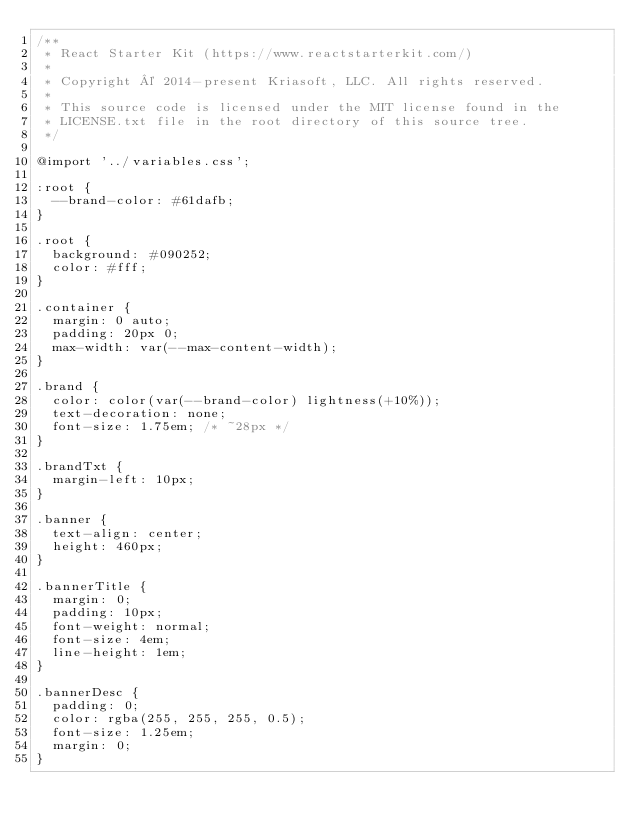<code> <loc_0><loc_0><loc_500><loc_500><_CSS_>/**
 * React Starter Kit (https://www.reactstarterkit.com/)
 *
 * Copyright © 2014-present Kriasoft, LLC. All rights reserved.
 *
 * This source code is licensed under the MIT license found in the
 * LICENSE.txt file in the root directory of this source tree.
 */

@import '../variables.css';

:root {
  --brand-color: #61dafb;
}

.root {
  background: #090252;
  color: #fff;
}

.container {
  margin: 0 auto;
  padding: 20px 0;
  max-width: var(--max-content-width);
}

.brand {
  color: color(var(--brand-color) lightness(+10%));
  text-decoration: none;
  font-size: 1.75em; /* ~28px */
}

.brandTxt {
  margin-left: 10px;
}

.banner {
  text-align: center;
  height: 460px;
}

.bannerTitle {
  margin: 0;
  padding: 10px;
  font-weight: normal;
  font-size: 4em;
  line-height: 1em;
}

.bannerDesc {
  padding: 0;
  color: rgba(255, 255, 255, 0.5);
  font-size: 1.25em;
  margin: 0;
}
</code> 